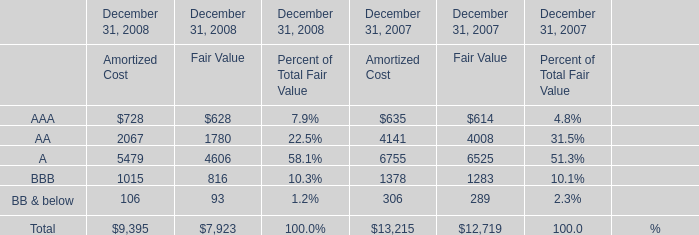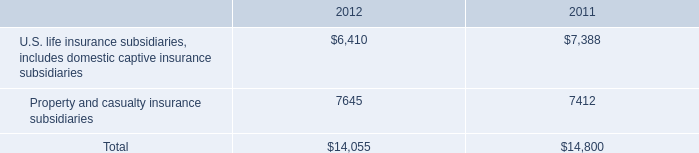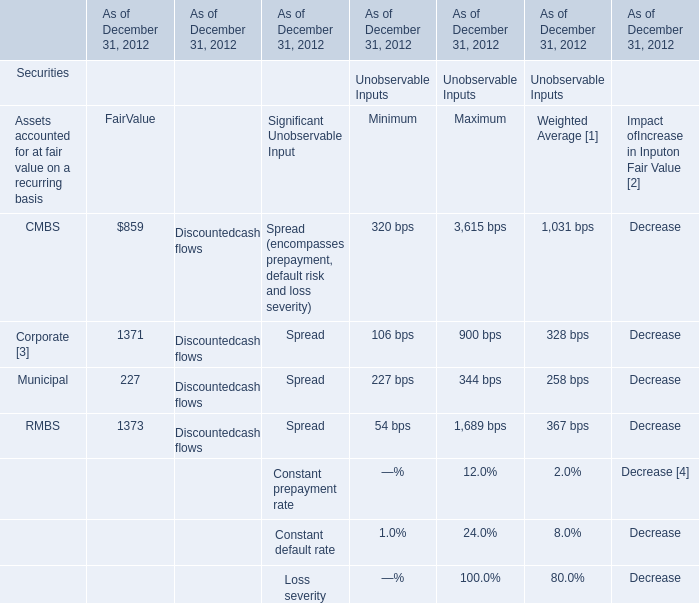How many FairValue exceed the average of FairValue in 2012? 
Answer: 2. 